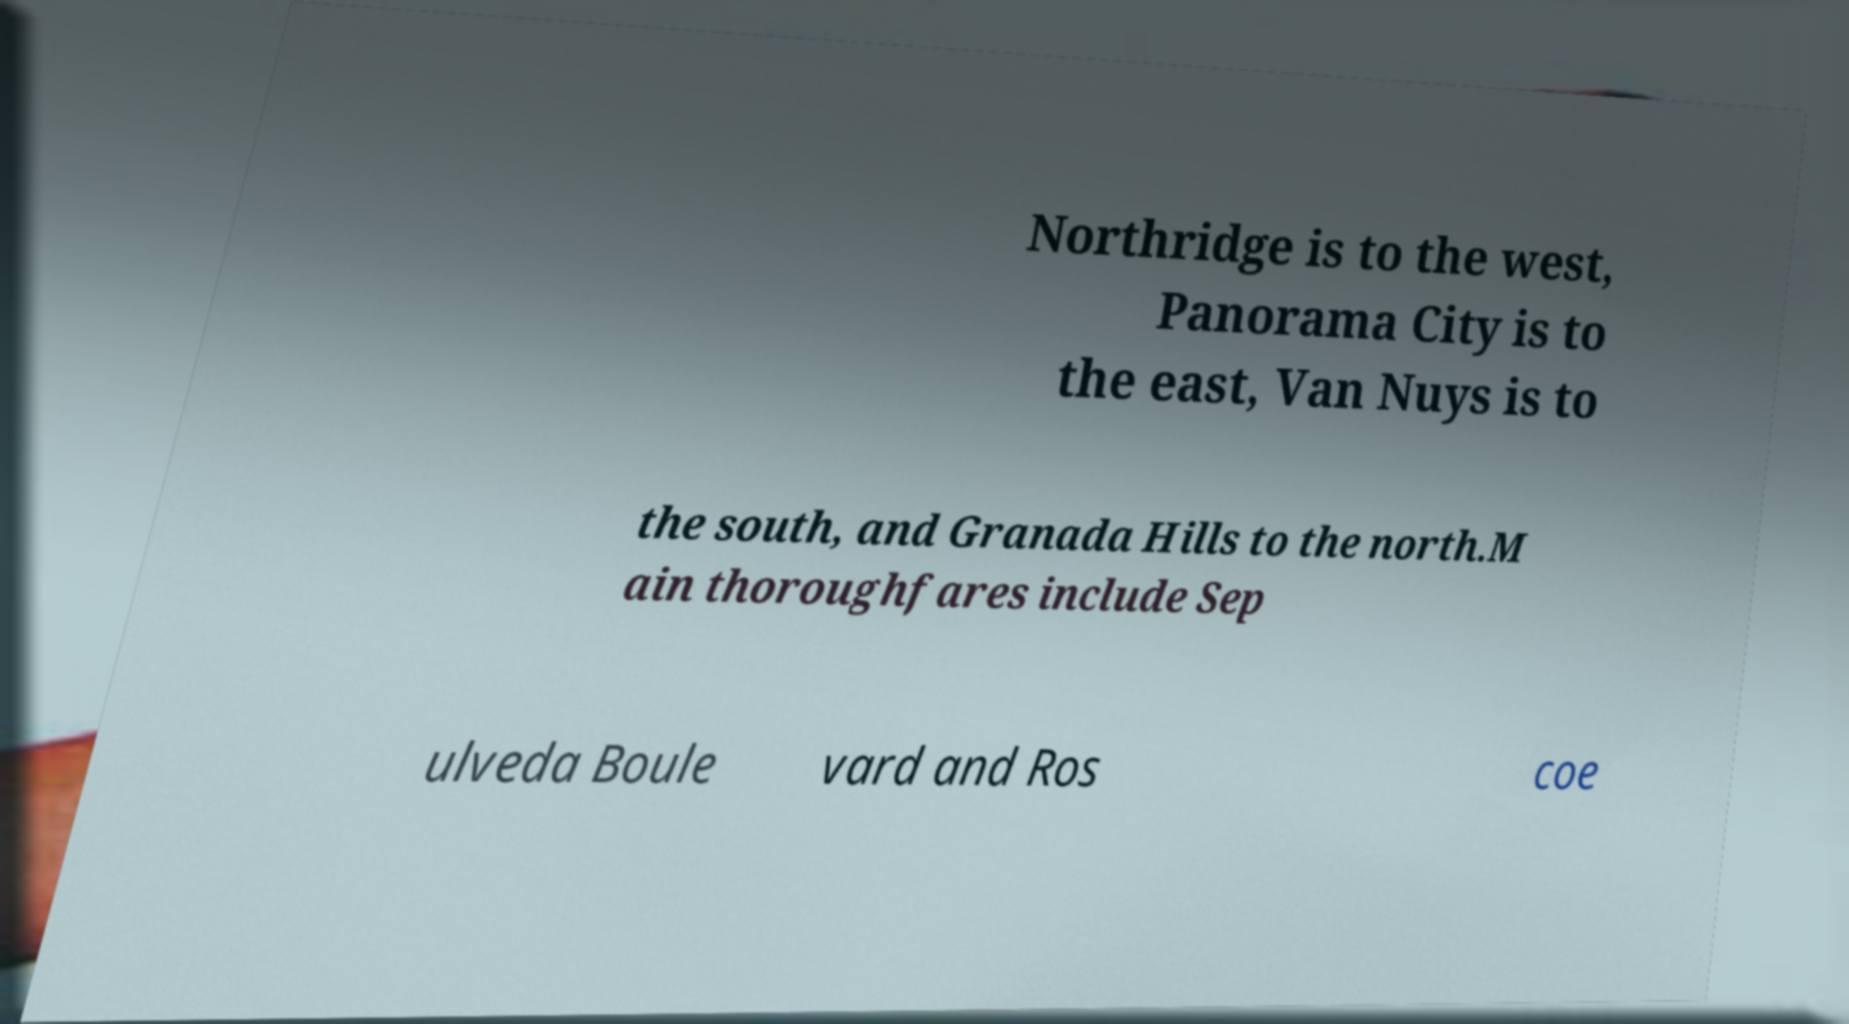I need the written content from this picture converted into text. Can you do that? Northridge is to the west, Panorama City is to the east, Van Nuys is to the south, and Granada Hills to the north.M ain thoroughfares include Sep ulveda Boule vard and Ros coe 